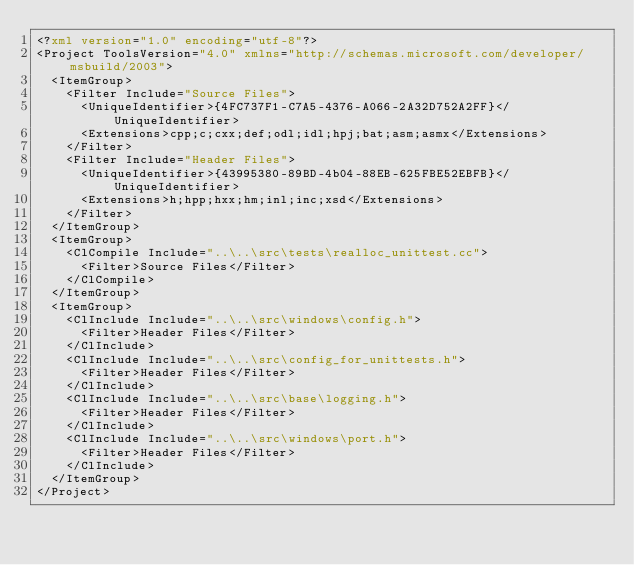<code> <loc_0><loc_0><loc_500><loc_500><_XML_><?xml version="1.0" encoding="utf-8"?>
<Project ToolsVersion="4.0" xmlns="http://schemas.microsoft.com/developer/msbuild/2003">
  <ItemGroup>
    <Filter Include="Source Files">
      <UniqueIdentifier>{4FC737F1-C7A5-4376-A066-2A32D752A2FF}</UniqueIdentifier>
      <Extensions>cpp;c;cxx;def;odl;idl;hpj;bat;asm;asmx</Extensions>
    </Filter>
    <Filter Include="Header Files">
      <UniqueIdentifier>{43995380-89BD-4b04-88EB-625FBE52EBFB}</UniqueIdentifier>
      <Extensions>h;hpp;hxx;hm;inl;inc;xsd</Extensions>
    </Filter>
  </ItemGroup>
  <ItemGroup>
    <ClCompile Include="..\..\src\tests\realloc_unittest.cc">
      <Filter>Source Files</Filter>
    </ClCompile>
  </ItemGroup>
  <ItemGroup>
    <ClInclude Include="..\..\src\windows\config.h">
      <Filter>Header Files</Filter>
    </ClInclude>
    <ClInclude Include="..\..\src\config_for_unittests.h">
      <Filter>Header Files</Filter>
    </ClInclude>
    <ClInclude Include="..\..\src\base\logging.h">
      <Filter>Header Files</Filter>
    </ClInclude>
    <ClInclude Include="..\..\src\windows\port.h">
      <Filter>Header Files</Filter>
    </ClInclude>
  </ItemGroup>
</Project></code> 